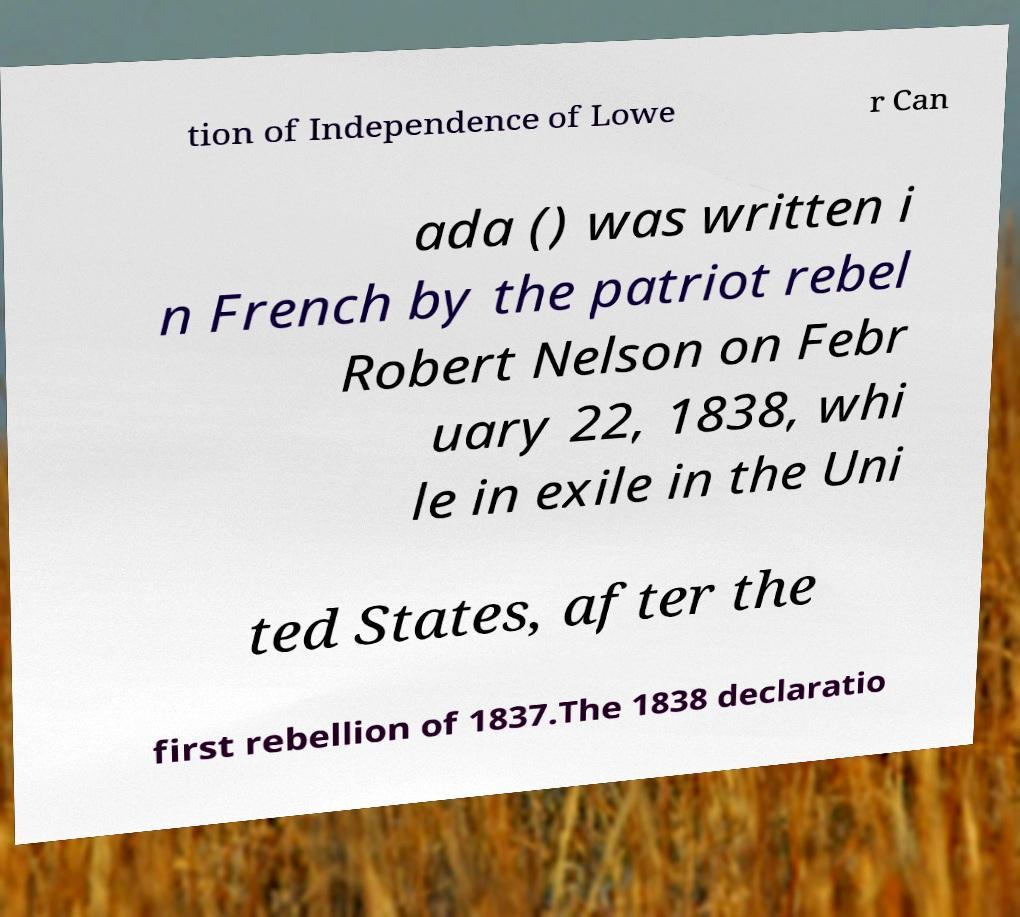Could you assist in decoding the text presented in this image and type it out clearly? tion of Independence of Lowe r Can ada () was written i n French by the patriot rebel Robert Nelson on Febr uary 22, 1838, whi le in exile in the Uni ted States, after the first rebellion of 1837.The 1838 declaratio 